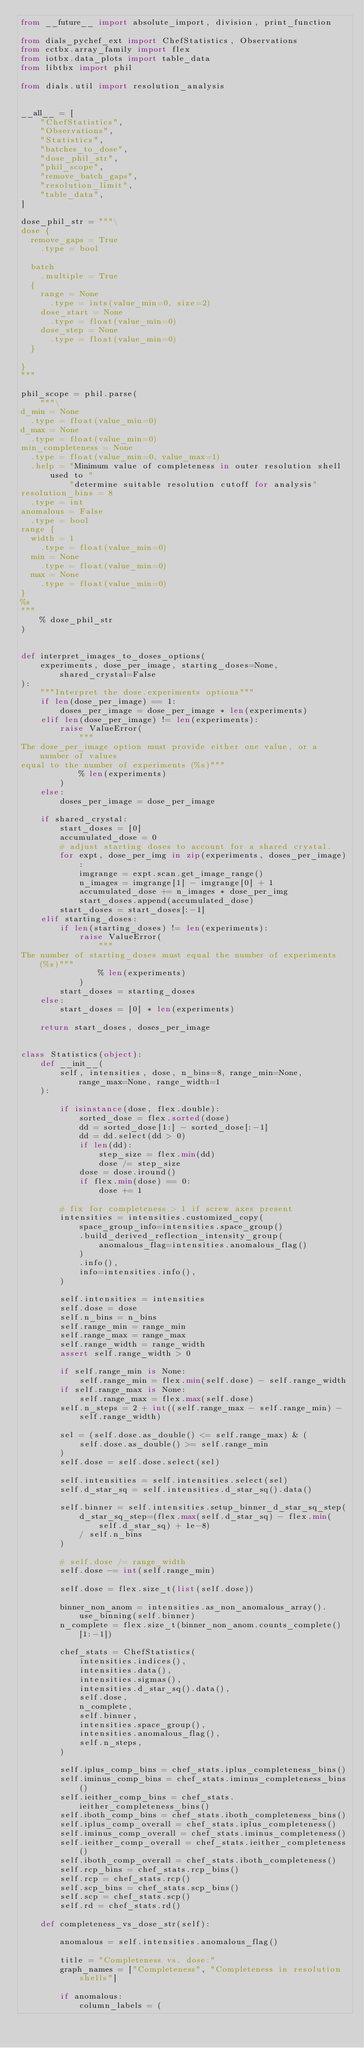<code> <loc_0><loc_0><loc_500><loc_500><_Python_>from __future__ import absolute_import, division, print_function

from dials_pychef_ext import ChefStatistics, Observations
from cctbx.array_family import flex
from iotbx.data_plots import table_data
from libtbx import phil

from dials.util import resolution_analysis


__all__ = [
    "ChefStatistics",
    "Observations",
    "Statistics",
    "batches_to_dose",
    "dose_phil_str",
    "phil_scope",
    "remove_batch_gaps",
    "resolution_limit",
    "table_data",
]

dose_phil_str = """\
dose {
  remove_gaps = True
    .type = bool

  batch
    .multiple = True
  {
    range = None
      .type = ints(value_min=0, size=2)
    dose_start = None
      .type = float(value_min=0)
    dose_step = None
      .type = float(value_min=0)
  }

}
"""

phil_scope = phil.parse(
    """\
d_min = None
  .type = float(value_min=0)
d_max = None
  .type = float(value_min=0)
min_completeness = None
  .type = float(value_min=0, value_max=1)
  .help = "Minimum value of completeness in outer resolution shell used to "
          "determine suitable resolution cutoff for analysis"
resolution_bins = 8
  .type = int
anomalous = False
  .type = bool
range {
  width = 1
    .type = float(value_min=0)
  min = None
    .type = float(value_min=0)
  max = None
    .type = float(value_min=0)
}
%s
"""
    % dose_phil_str
)


def interpret_images_to_doses_options(
    experiments, dose_per_image, starting_doses=None, shared_crystal=False
):
    """Interpret the dose.experiments options"""
    if len(dose_per_image) == 1:
        doses_per_image = dose_per_image * len(experiments)
    elif len(dose_per_image) != len(experiments):
        raise ValueError(
            """
The dose_per_image option must provide either one value, or a number of values
equal to the number of experiments (%s)"""
            % len(experiments)
        )
    else:
        doses_per_image = dose_per_image

    if shared_crystal:
        start_doses = [0]
        accumulated_dose = 0
        # adjust starting doses to account for a shared crystal.
        for expt, dose_per_img in zip(experiments, doses_per_image):
            imgrange = expt.scan.get_image_range()
            n_images = imgrange[1] - imgrange[0] + 1
            accumulated_dose += n_images * dose_per_img
            start_doses.append(accumulated_dose)
        start_doses = start_doses[:-1]
    elif starting_doses:
        if len(starting_doses) != len(experiments):
            raise ValueError(
                """
The number of starting_doses must equal the number of experiments (%s)"""
                % len(experiments)
            )
        start_doses = starting_doses
    else:
        start_doses = [0] * len(experiments)

    return start_doses, doses_per_image


class Statistics(object):
    def __init__(
        self, intensities, dose, n_bins=8, range_min=None, range_max=None, range_width=1
    ):

        if isinstance(dose, flex.double):
            sorted_dose = flex.sorted(dose)
            dd = sorted_dose[1:] - sorted_dose[:-1]
            dd = dd.select(dd > 0)
            if len(dd):
                step_size = flex.min(dd)
                dose /= step_size
            dose = dose.iround()
            if flex.min(dose) == 0:
                dose += 1

        # fix for completeness > 1 if screw axes present
        intensities = intensities.customized_copy(
            space_group_info=intensities.space_group()
            .build_derived_reflection_intensity_group(
                anomalous_flag=intensities.anomalous_flag()
            )
            .info(),
            info=intensities.info(),
        )

        self.intensities = intensities
        self.dose = dose
        self.n_bins = n_bins
        self.range_min = range_min
        self.range_max = range_max
        self.range_width = range_width
        assert self.range_width > 0

        if self.range_min is None:
            self.range_min = flex.min(self.dose) - self.range_width
        if self.range_max is None:
            self.range_max = flex.max(self.dose)
        self.n_steps = 2 + int((self.range_max - self.range_min) - self.range_width)

        sel = (self.dose.as_double() <= self.range_max) & (
            self.dose.as_double() >= self.range_min
        )
        self.dose = self.dose.select(sel)

        self.intensities = self.intensities.select(sel)
        self.d_star_sq = self.intensities.d_star_sq().data()

        self.binner = self.intensities.setup_binner_d_star_sq_step(
            d_star_sq_step=(flex.max(self.d_star_sq) - flex.min(self.d_star_sq) + 1e-8)
            / self.n_bins
        )

        # self.dose /= range_width
        self.dose -= int(self.range_min)

        self.dose = flex.size_t(list(self.dose))

        binner_non_anom = intensities.as_non_anomalous_array().use_binning(self.binner)
        n_complete = flex.size_t(binner_non_anom.counts_complete()[1:-1])

        chef_stats = ChefStatistics(
            intensities.indices(),
            intensities.data(),
            intensities.sigmas(),
            intensities.d_star_sq().data(),
            self.dose,
            n_complete,
            self.binner,
            intensities.space_group(),
            intensities.anomalous_flag(),
            self.n_steps,
        )

        self.iplus_comp_bins = chef_stats.iplus_completeness_bins()
        self.iminus_comp_bins = chef_stats.iminus_completeness_bins()
        self.ieither_comp_bins = chef_stats.ieither_completeness_bins()
        self.iboth_comp_bins = chef_stats.iboth_completeness_bins()
        self.iplus_comp_overall = chef_stats.iplus_completeness()
        self.iminus_comp_overall = chef_stats.iminus_completeness()
        self.ieither_comp_overall = chef_stats.ieither_completeness()
        self.iboth_comp_overall = chef_stats.iboth_completeness()
        self.rcp_bins = chef_stats.rcp_bins()
        self.rcp = chef_stats.rcp()
        self.scp_bins = chef_stats.scp_bins()
        self.scp = chef_stats.scp()
        self.rd = chef_stats.rd()

    def completeness_vs_dose_str(self):

        anomalous = self.intensities.anomalous_flag()

        title = "Completeness vs. dose:"
        graph_names = ["Completeness", "Completeness in resolution shells"]

        if anomalous:
            column_labels = (</code> 